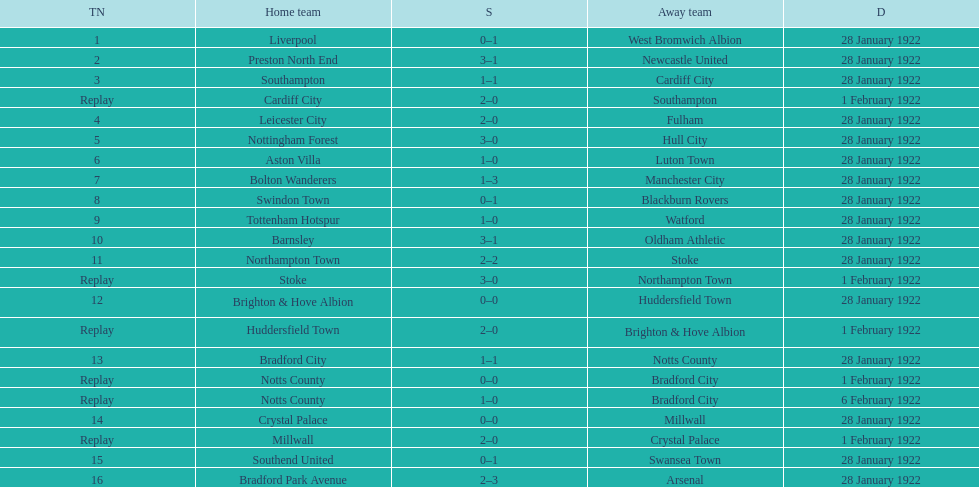What home team had the same score as aston villa on january 28th, 1922? Tottenham Hotspur. 